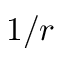Convert formula to latex. <formula><loc_0><loc_0><loc_500><loc_500>1 / r</formula> 